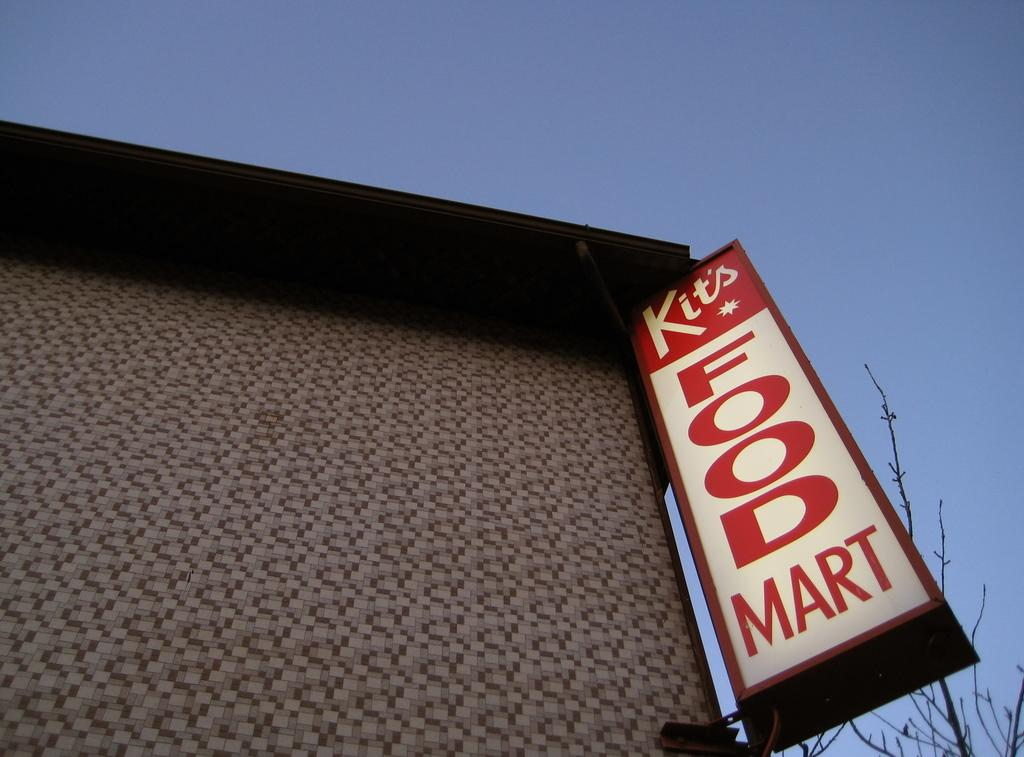What is visible at the top of the image? The sky is visible at the top of the image. What type of advertisement or signage is present in the image? There is a hoarding board in the image. What type of vegetation can be seen on the right side of the image? There are branches on the right side of the image. How many eggs are sitting on the chair in the image? There is no chair or eggs present in the image. What type of chair is visible in the image? There is no chair present in the image. 